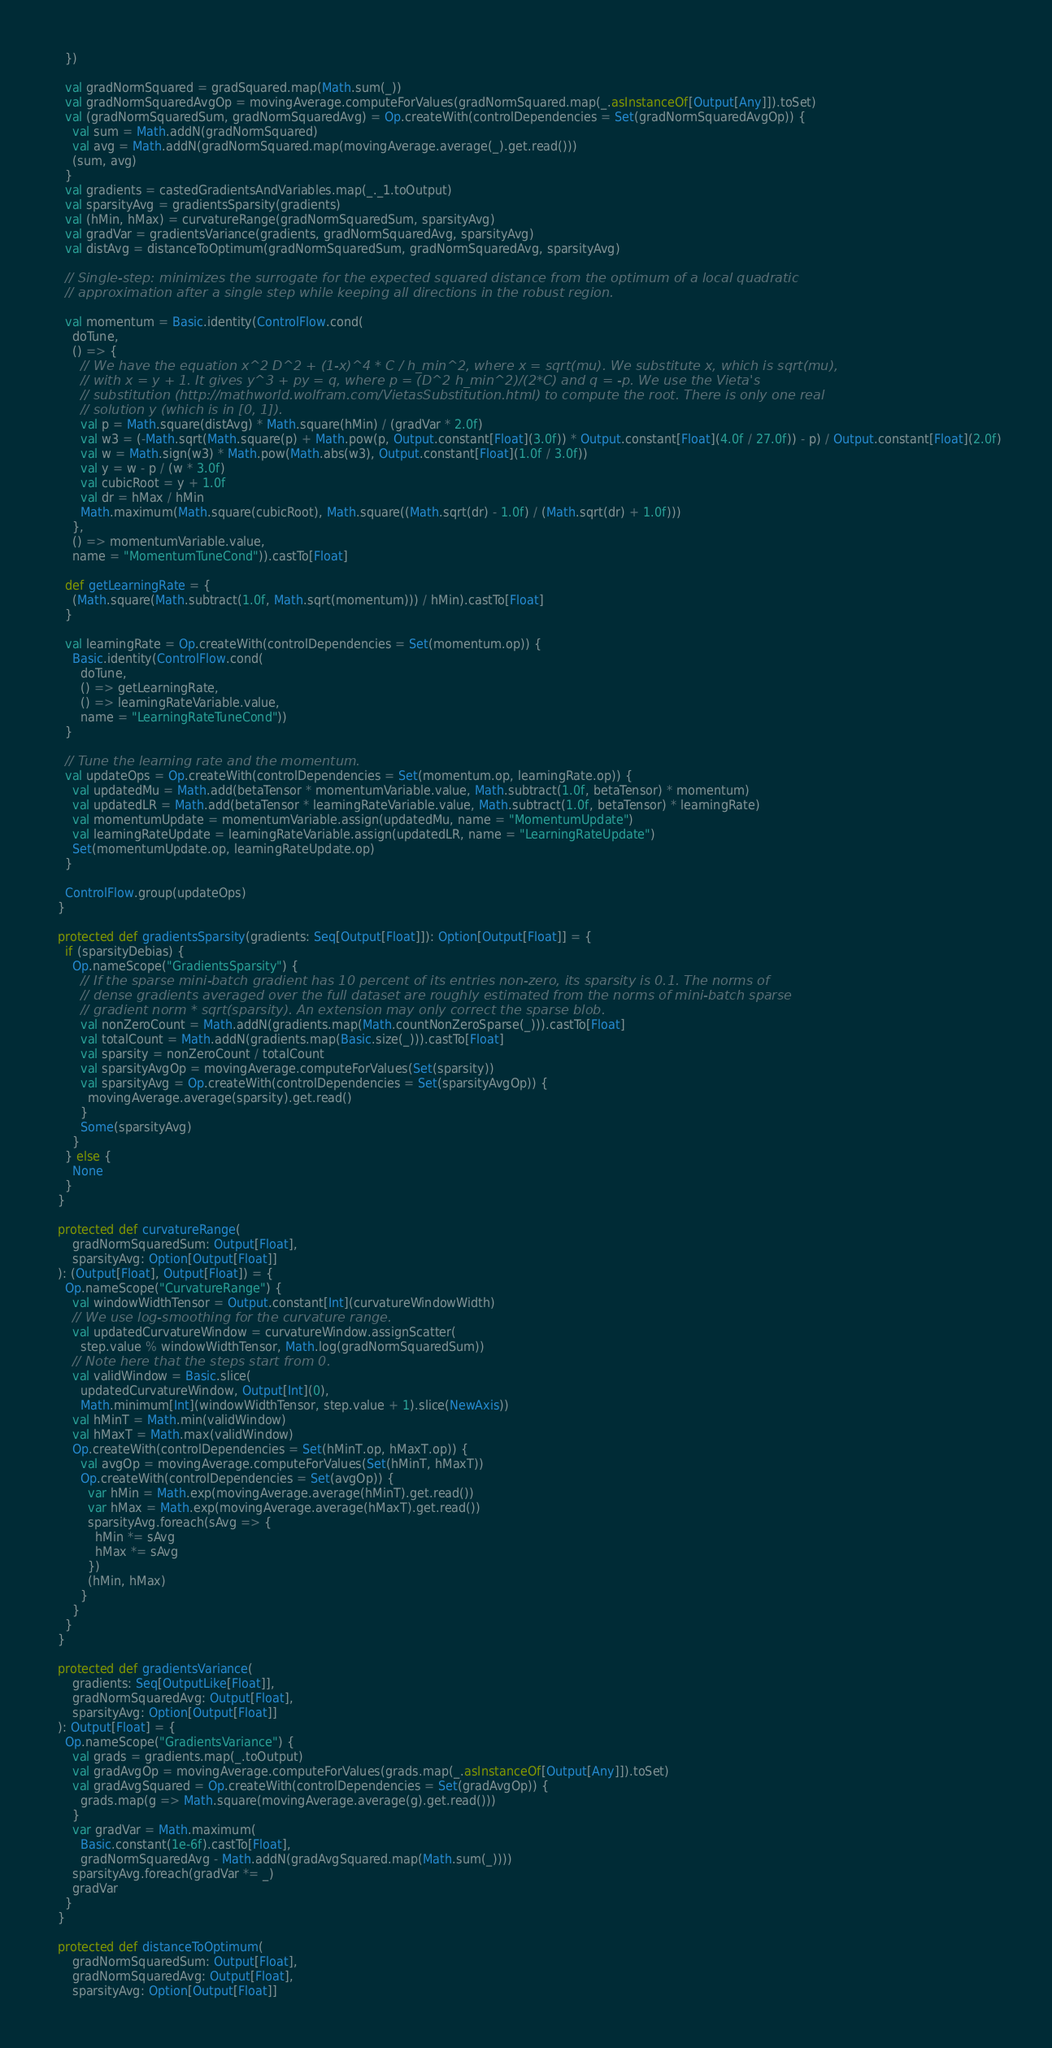<code> <loc_0><loc_0><loc_500><loc_500><_Scala_>    })

    val gradNormSquared = gradSquared.map(Math.sum(_))
    val gradNormSquaredAvgOp = movingAverage.computeForValues(gradNormSquared.map(_.asInstanceOf[Output[Any]]).toSet)
    val (gradNormSquaredSum, gradNormSquaredAvg) = Op.createWith(controlDependencies = Set(gradNormSquaredAvgOp)) {
      val sum = Math.addN(gradNormSquared)
      val avg = Math.addN(gradNormSquared.map(movingAverage.average(_).get.read()))
      (sum, avg)
    }
    val gradients = castedGradientsAndVariables.map(_._1.toOutput)
    val sparsityAvg = gradientsSparsity(gradients)
    val (hMin, hMax) = curvatureRange(gradNormSquaredSum, sparsityAvg)
    val gradVar = gradientsVariance(gradients, gradNormSquaredAvg, sparsityAvg)
    val distAvg = distanceToOptimum(gradNormSquaredSum, gradNormSquaredAvg, sparsityAvg)

    // Single-step: minimizes the surrogate for the expected squared distance from the optimum of a local quadratic
    // approximation after a single step while keeping all directions in the robust region.

    val momentum = Basic.identity(ControlFlow.cond(
      doTune,
      () => {
        // We have the equation x^2 D^2 + (1-x)^4 * C / h_min^2, where x = sqrt(mu). We substitute x, which is sqrt(mu),
        // with x = y + 1. It gives y^3 + py = q, where p = (D^2 h_min^2)/(2*C) and q = -p. We use the Vieta's
        // substitution (http://mathworld.wolfram.com/VietasSubstitution.html) to compute the root. There is only one real
        // solution y (which is in [0, 1]).
        val p = Math.square(distAvg) * Math.square(hMin) / (gradVar * 2.0f)
        val w3 = (-Math.sqrt(Math.square(p) + Math.pow(p, Output.constant[Float](3.0f)) * Output.constant[Float](4.0f / 27.0f)) - p) / Output.constant[Float](2.0f)
        val w = Math.sign(w3) * Math.pow(Math.abs(w3), Output.constant[Float](1.0f / 3.0f))
        val y = w - p / (w * 3.0f)
        val cubicRoot = y + 1.0f
        val dr = hMax / hMin
        Math.maximum(Math.square(cubicRoot), Math.square((Math.sqrt(dr) - 1.0f) / (Math.sqrt(dr) + 1.0f)))
      },
      () => momentumVariable.value,
      name = "MomentumTuneCond")).castTo[Float]

    def getLearningRate = {
      (Math.square(Math.subtract(1.0f, Math.sqrt(momentum))) / hMin).castTo[Float]
    }

    val learningRate = Op.createWith(controlDependencies = Set(momentum.op)) {
      Basic.identity(ControlFlow.cond(
        doTune,
        () => getLearningRate,
        () => learningRateVariable.value,
        name = "LearningRateTuneCond"))
    }

    // Tune the learning rate and the momentum.
    val updateOps = Op.createWith(controlDependencies = Set(momentum.op, learningRate.op)) {
      val updatedMu = Math.add(betaTensor * momentumVariable.value, Math.subtract(1.0f, betaTensor) * momentum)
      val updatedLR = Math.add(betaTensor * learningRateVariable.value, Math.subtract(1.0f, betaTensor) * learningRate)
      val momentumUpdate = momentumVariable.assign(updatedMu, name = "MomentumUpdate")
      val learningRateUpdate = learningRateVariable.assign(updatedLR, name = "LearningRateUpdate")
      Set(momentumUpdate.op, learningRateUpdate.op)
    }

    ControlFlow.group(updateOps)
  }

  protected def gradientsSparsity(gradients: Seq[Output[Float]]): Option[Output[Float]] = {
    if (sparsityDebias) {
      Op.nameScope("GradientsSparsity") {
        // If the sparse mini-batch gradient has 10 percent of its entries non-zero, its sparsity is 0.1. The norms of
        // dense gradients averaged over the full dataset are roughly estimated from the norms of mini-batch sparse
        // gradient norm * sqrt(sparsity). An extension may only correct the sparse blob.
        val nonZeroCount = Math.addN(gradients.map(Math.countNonZeroSparse(_))).castTo[Float]
        val totalCount = Math.addN(gradients.map(Basic.size(_))).castTo[Float]
        val sparsity = nonZeroCount / totalCount
        val sparsityAvgOp = movingAverage.computeForValues(Set(sparsity))
        val sparsityAvg = Op.createWith(controlDependencies = Set(sparsityAvgOp)) {
          movingAverage.average(sparsity).get.read()
        }
        Some(sparsityAvg)
      }
    } else {
      None
    }
  }

  protected def curvatureRange(
      gradNormSquaredSum: Output[Float],
      sparsityAvg: Option[Output[Float]]
  ): (Output[Float], Output[Float]) = {
    Op.nameScope("CurvatureRange") {
      val windowWidthTensor = Output.constant[Int](curvatureWindowWidth)
      // We use log-smoothing for the curvature range.
      val updatedCurvatureWindow = curvatureWindow.assignScatter(
        step.value % windowWidthTensor, Math.log(gradNormSquaredSum))
      // Note here that the steps start from 0.
      val validWindow = Basic.slice(
        updatedCurvatureWindow, Output[Int](0),
        Math.minimum[Int](windowWidthTensor, step.value + 1).slice(NewAxis))
      val hMinT = Math.min(validWindow)
      val hMaxT = Math.max(validWindow)
      Op.createWith(controlDependencies = Set(hMinT.op, hMaxT.op)) {
        val avgOp = movingAverage.computeForValues(Set(hMinT, hMaxT))
        Op.createWith(controlDependencies = Set(avgOp)) {
          var hMin = Math.exp(movingAverage.average(hMinT).get.read())
          var hMax = Math.exp(movingAverage.average(hMaxT).get.read())
          sparsityAvg.foreach(sAvg => {
            hMin *= sAvg
            hMax *= sAvg
          })
          (hMin, hMax)
        }
      }
    }
  }

  protected def gradientsVariance(
      gradients: Seq[OutputLike[Float]],
      gradNormSquaredAvg: Output[Float],
      sparsityAvg: Option[Output[Float]]
  ): Output[Float] = {
    Op.nameScope("GradientsVariance") {
      val grads = gradients.map(_.toOutput)
      val gradAvgOp = movingAverage.computeForValues(grads.map(_.asInstanceOf[Output[Any]]).toSet)
      val gradAvgSquared = Op.createWith(controlDependencies = Set(gradAvgOp)) {
        grads.map(g => Math.square(movingAverage.average(g).get.read()))
      }
      var gradVar = Math.maximum(
        Basic.constant(1e-6f).castTo[Float],
        gradNormSquaredAvg - Math.addN(gradAvgSquared.map(Math.sum(_))))
      sparsityAvg.foreach(gradVar *= _)
      gradVar
    }
  }

  protected def distanceToOptimum(
      gradNormSquaredSum: Output[Float],
      gradNormSquaredAvg: Output[Float],
      sparsityAvg: Option[Output[Float]]</code> 